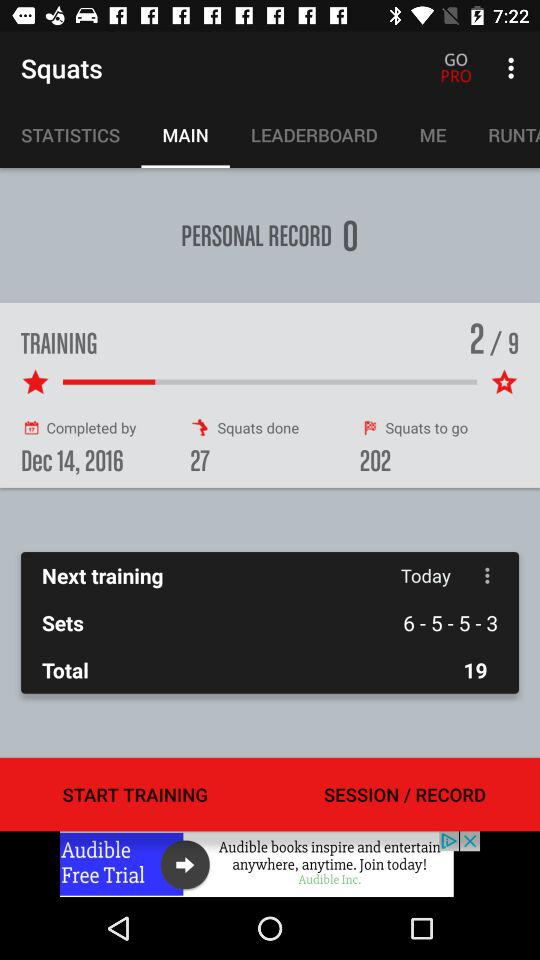At which training i am at?
When the provided information is insufficient, respond with <no answer>. <no answer> 